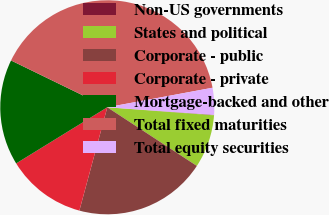Convert chart. <chart><loc_0><loc_0><loc_500><loc_500><pie_chart><fcel>Non-US governments<fcel>States and political<fcel>Corporate - public<fcel>Corporate - private<fcel>Mortgage-backed and other<fcel>Total fixed maturities<fcel>Total equity securities<nl><fcel>0.07%<fcel>8.03%<fcel>19.97%<fcel>12.01%<fcel>15.99%<fcel>39.87%<fcel>4.05%<nl></chart> 